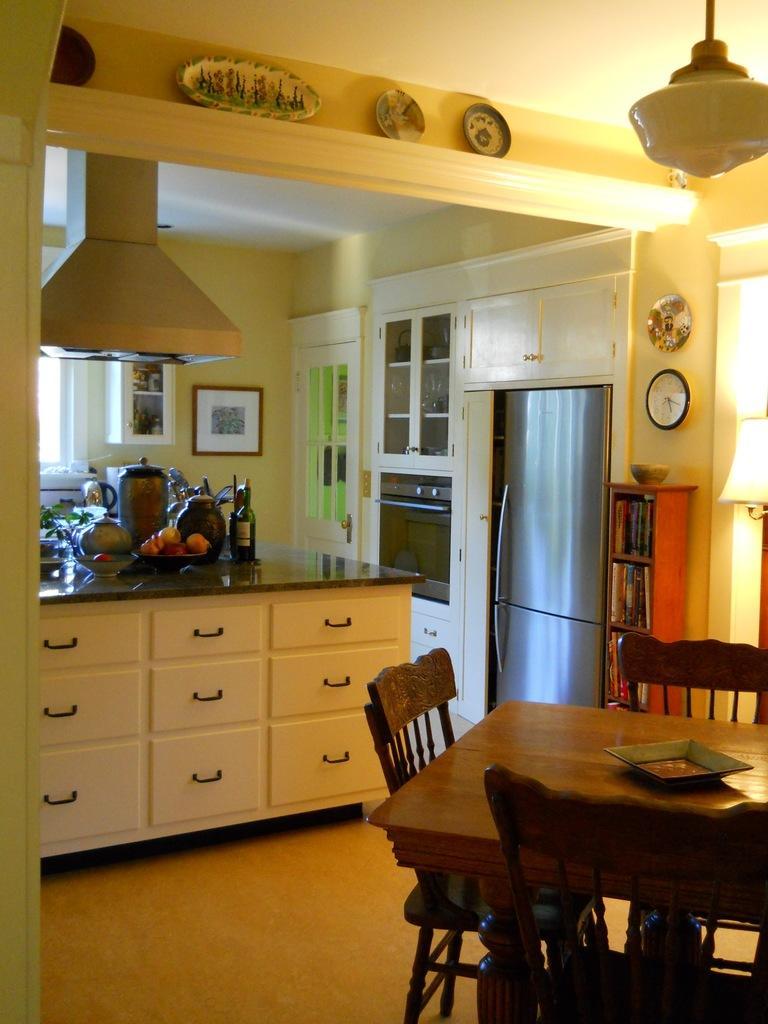In one or two sentences, can you explain what this image depicts? In this image I can see a table, chairs, door, books, kitchen cabinet on which I can see fruits, vegetables, bottles and so on. In the background I can see a wall, window, photo frame, chimney, clock and lights. This image is taken may be in a room. 